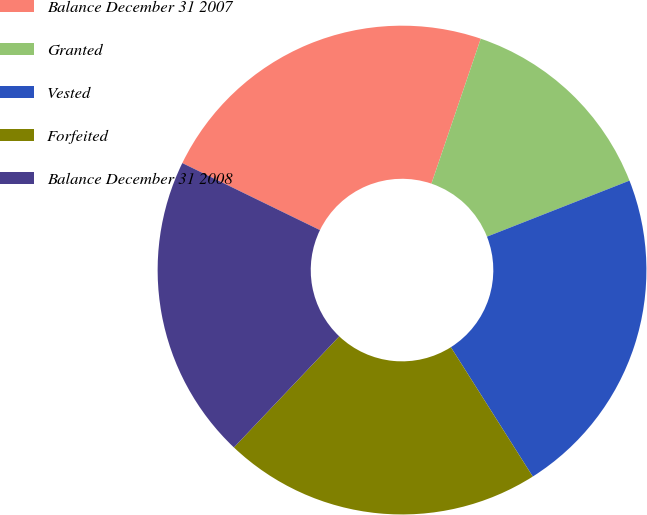<chart> <loc_0><loc_0><loc_500><loc_500><pie_chart><fcel>Balance December 31 2007<fcel>Granted<fcel>Vested<fcel>Forfeited<fcel>Balance December 31 2008<nl><fcel>23.01%<fcel>13.82%<fcel>21.98%<fcel>21.06%<fcel>20.14%<nl></chart> 